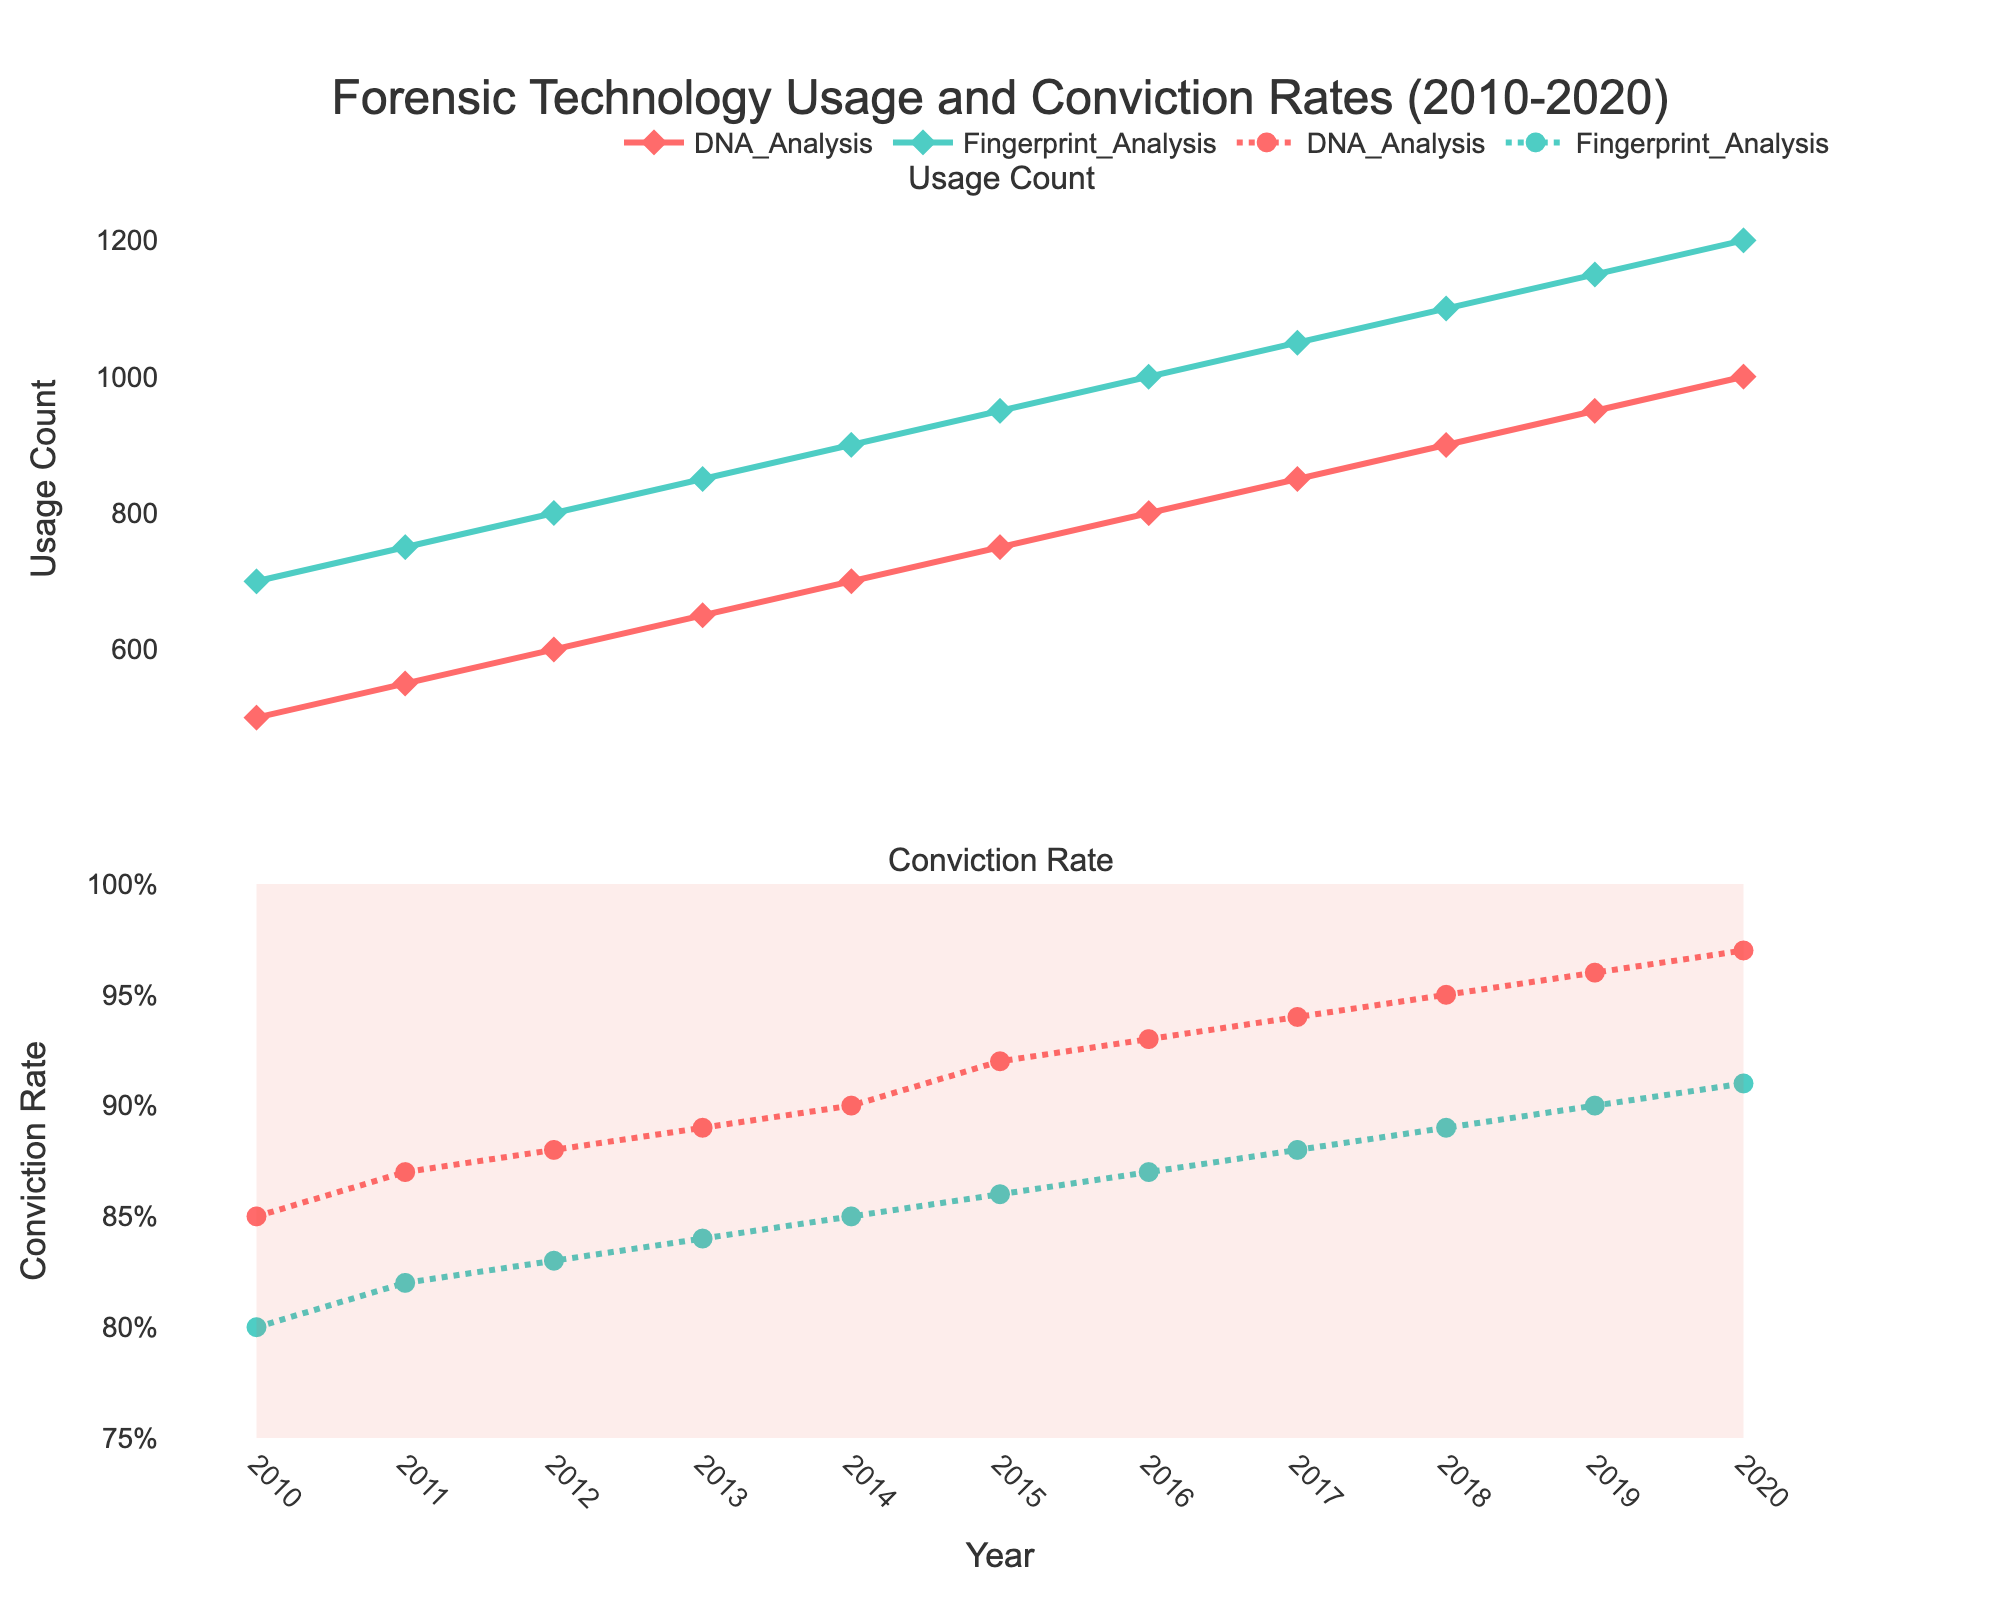What's the title of the figure? The title is given at the top of the figure. It provides a summary of the visual information shown.
Answer: Forensic Technology Usage and Conviction Rates (2010-2020) How does the usage count of DNA Analysis compare to Fingerprint Analysis in 2015? Look at the 'Usage Count' subplot for the year 2015 and compare the markers for both technologies.
Answer: DNA Analysis: 750, Fingerprint Analysis: 950 What trend do you observe in the conviction rate for DNA Analysis from 2010 to 2020? Examine the 'Conviction Rate' subplot. Observe the line for DNA Analysis from 2010 to 2020 and note the general direction of change.
Answer: Increasing trend What was the conviction rate for Fingerprint Analysis in 2018? Check the 'Conviction Rate' subplot and locate the data point for Fingerprint Analysis in 2018.
Answer: 0.89 In which year did Fingerprint Analysis first surpass 800 in usage count? Look at the 'Usage Count' subplot and identify the year when Fingerprint Analysis data points cross the 800 mark.
Answer: 2012 Which technology had a higher increase in usage count from 2010 to 2020? Calculate the difference in usage counts for both technologies from 2010 to 2020, then compare the differences. DNA Analysis: 1000 - 500 = 500, Fingerprint Analysis: 1200 - 700 = 500
Answer: Both increased by 500 What can you infer about the relationship between the usage of forensic technologies and conviction rates over time? Observe both subplots. Note that as usage counts increase over time, the conviction rates also show an upward trend, suggesting a positive relationship.
Answer: Increase in usage correlates with higher conviction rates Which technology had a consistently higher conviction rate throughout the given period? Compare the lines in the 'Conviction Rate' subplot; see which technology's line is always above the other.
Answer: DNA Analysis 